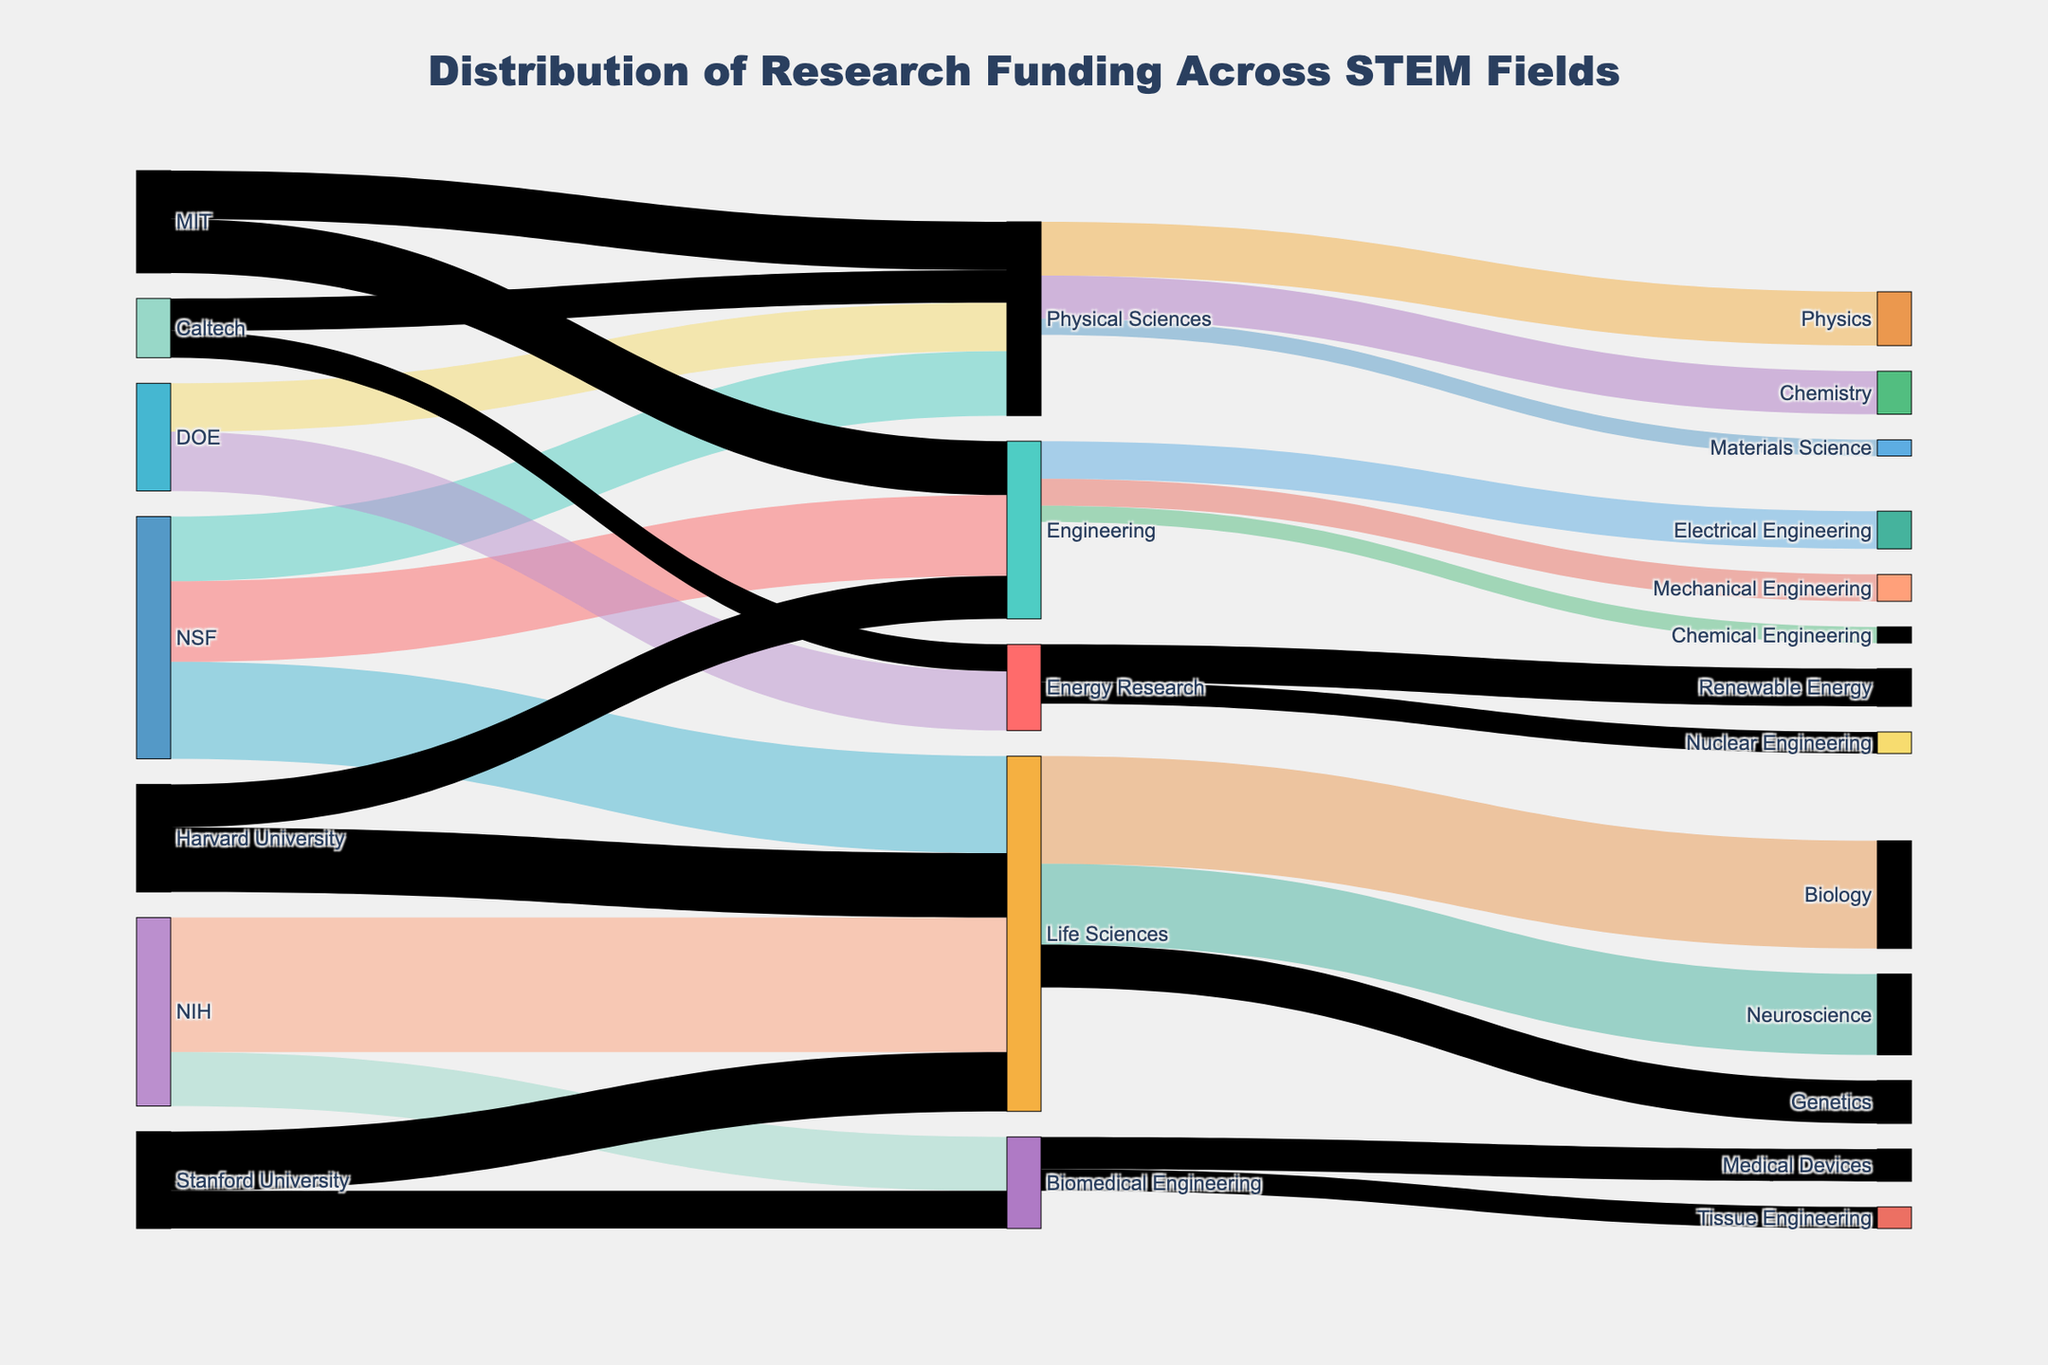What is the total amount of funding from NSF? To find the total NSF funding, sum the values of all links originating from NSF: 150 (Engineering) + 120 (Physical Sciences) + 180 (Life Sciences).
Answer: 450 Which STEM field receives the highest funding from NIH? Look at the link values from NIH to different fields: Life Sciences (250) and Biomedical Engineering (100). The higher value is 250 for Life Sciences.
Answer: Life Sciences How much funding does Harvard University allocate to Life Sciences? Locate the link between Harvard University and Life Sciences. The value is 120.
Answer: 120 Compare the funding received by Life Sciences from NSF and NIH. Which is higher and by how much? NSF to Life Sciences: 180, NIH to Life Sciences: 250. The difference is 250 - 180 = 70, NIH funding is higher.
Answer: NIH by 70 How many different STEM fields are funded by DOE? Count the number of unique STEM fields targeted by DOE: Physical Sciences, Energy Research.
Answer: 2 Which field within Engineering receives the highest amount of funding? Look at the values for Electrical Engineering (70), Mechanical Engineering (50), and Chemical Engineering (30). The highest value is 70 for Electrical Engineering.
Answer: Electrical Engineering What is the combined funding amount for Physical Sciences from all sources? Sum the values targeting Physical Sciences: NSF (120), DOE (90), MIT (90), Caltech (60). The total is 120 + 90 + 90 + 60 = 360.
Answer: 360 How much total funding is allocated to Energy Research across all universities? Look at the links targeting Energy Research: DOE (110) and Caltech (50). The combined total is 110 + 50 = 160.
Answer: 160 Which university allocates the most funding to Engineering? Look at the funding amounts for Engineering from different universities: Harvard (80) and MIT (100). MIT allocates the most with 100.
Answer: MIT Find the total funding received by Stanford University. Sum all funds targeting Stanford: Life Sciences (110) + Biomedical Engineering (70). The total is 110 + 70 = 180.
Answer: 180 